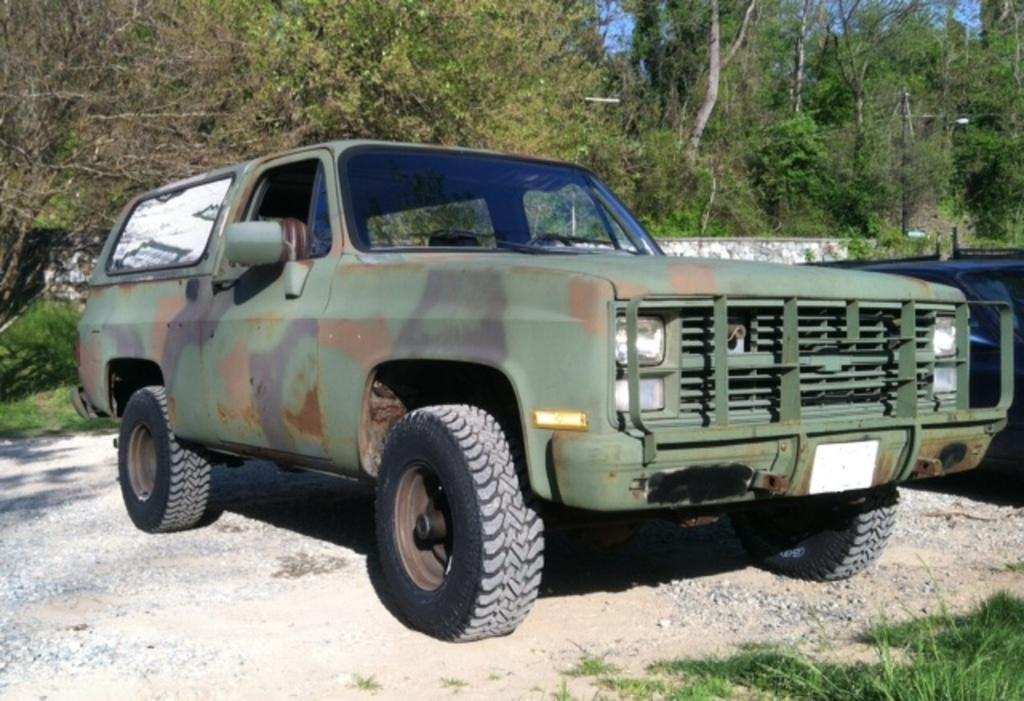What is the main subject in the foreground of the image? There is a vehicle in the foreground of the image. Can you describe the position of the vehicle in the image? The vehicle is on the ground. What type of vegetation can be seen on the bottom right side of the image? There is green grass on the bottom right side of the image. What can be seen in the background of the image? There is a wall fencing and trees in the background of the image. What type of dinner is being served in the image? There is no dinner present in the image; it features a vehicle on the ground with green grass, wall fencing, and trees in the background. 